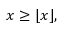<formula> <loc_0><loc_0><loc_500><loc_500>x \geq \lfloor x \rfloor ,</formula> 